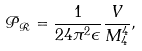Convert formula to latex. <formula><loc_0><loc_0><loc_500><loc_500>\mathcal { P } _ { \mathcal { R } } = \frac { 1 } { 2 4 \pi ^ { 2 } \epsilon } \frac { V } { M _ { 4 } ^ { 4 } } ,</formula> 